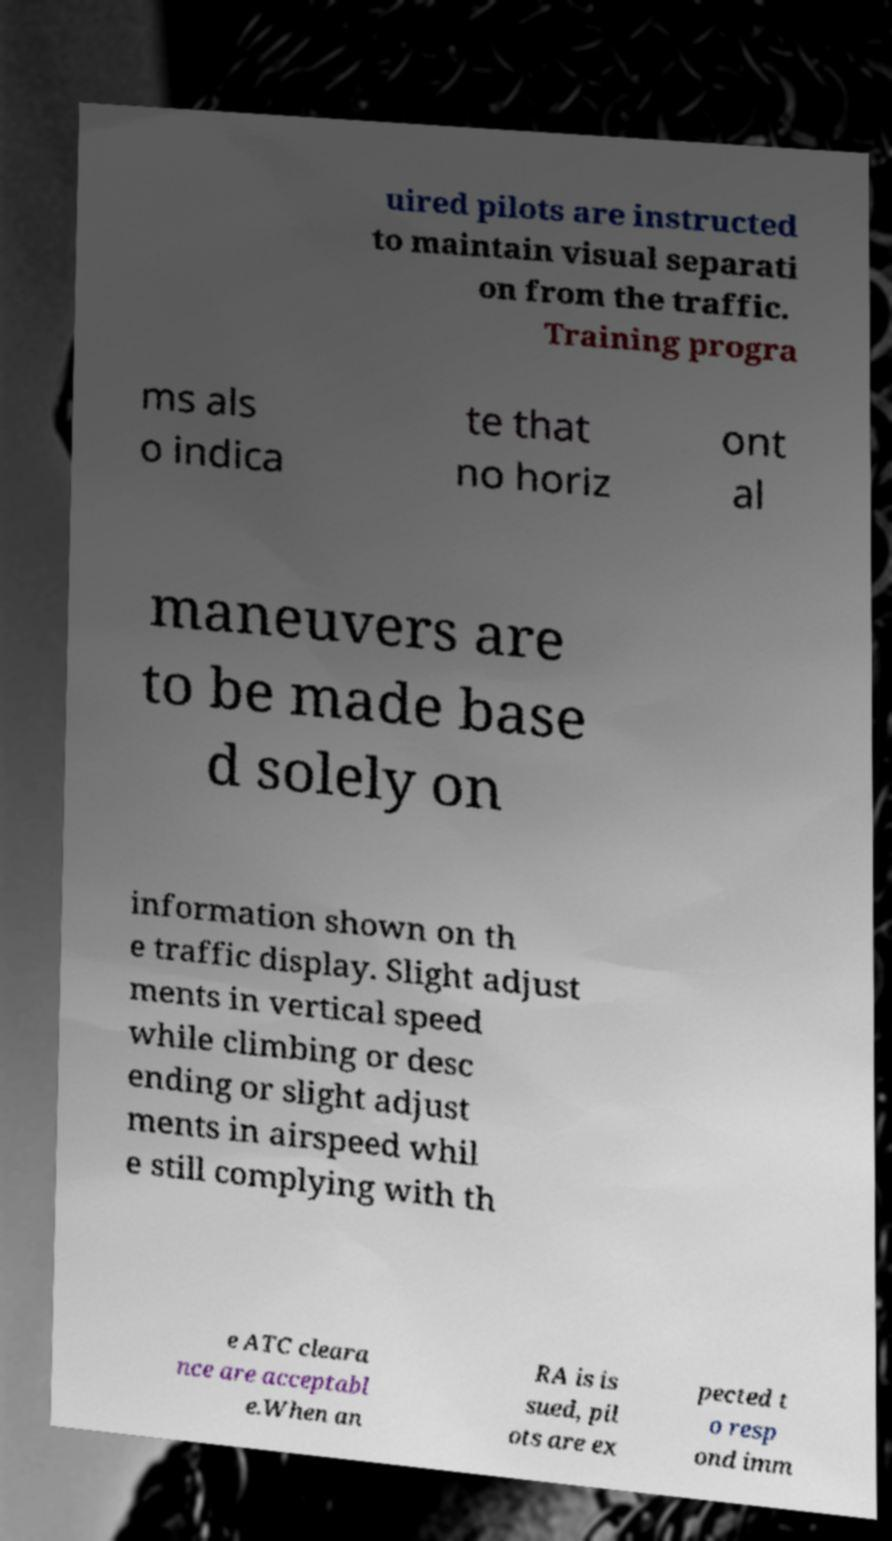Can you read and provide the text displayed in the image?This photo seems to have some interesting text. Can you extract and type it out for me? uired pilots are instructed to maintain visual separati on from the traffic. Training progra ms als o indica te that no horiz ont al maneuvers are to be made base d solely on information shown on th e traffic display. Slight adjust ments in vertical speed while climbing or desc ending or slight adjust ments in airspeed whil e still complying with th e ATC cleara nce are acceptabl e.When an RA is is sued, pil ots are ex pected t o resp ond imm 